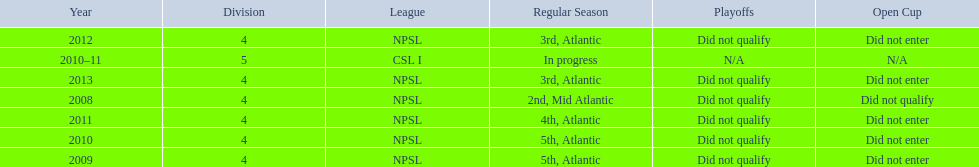What was the last year they came in 3rd place 2013. 